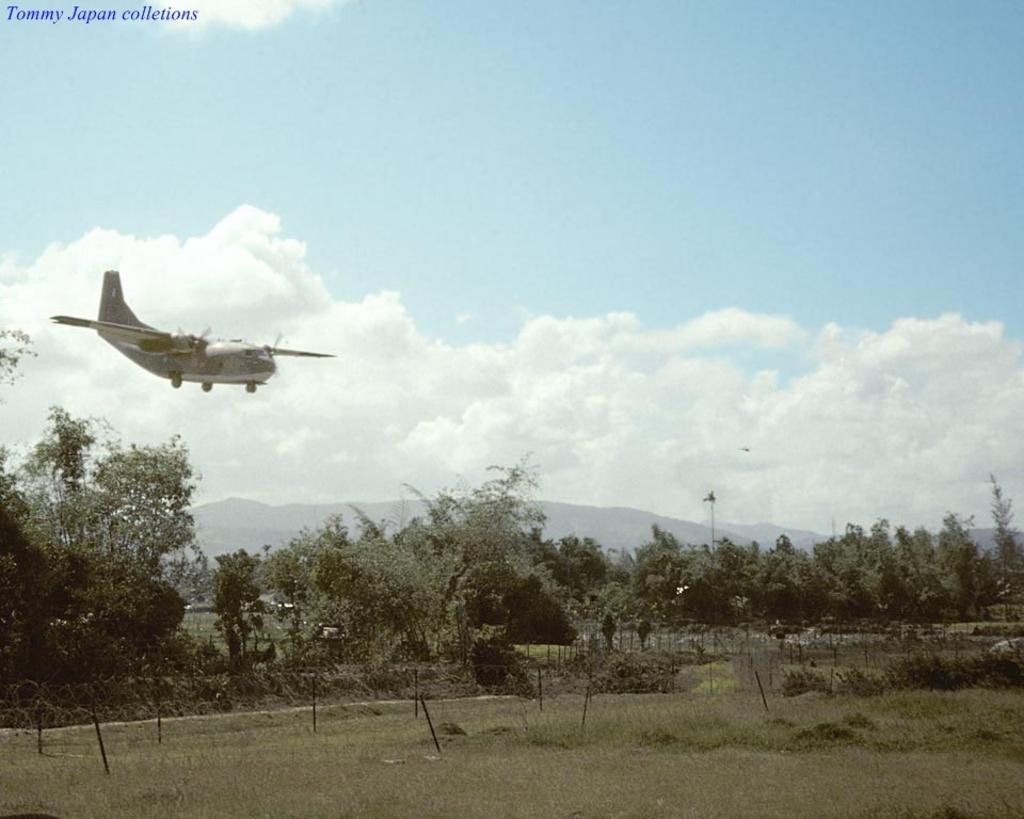What type of landscape is depicted in the image? There is a grassland in the image. What can be seen in the distance behind the grassland? There are trees and mountains in the background of the image. What is flying in the sky in the image? A flight is visible in the sky. What is present in the top left corner of the image? There is text in the top left corner of the image. How many giants are walking through the grassland in the image? There are no giants present in the image; it features a grassland with trees, mountains, a flight, and text. 